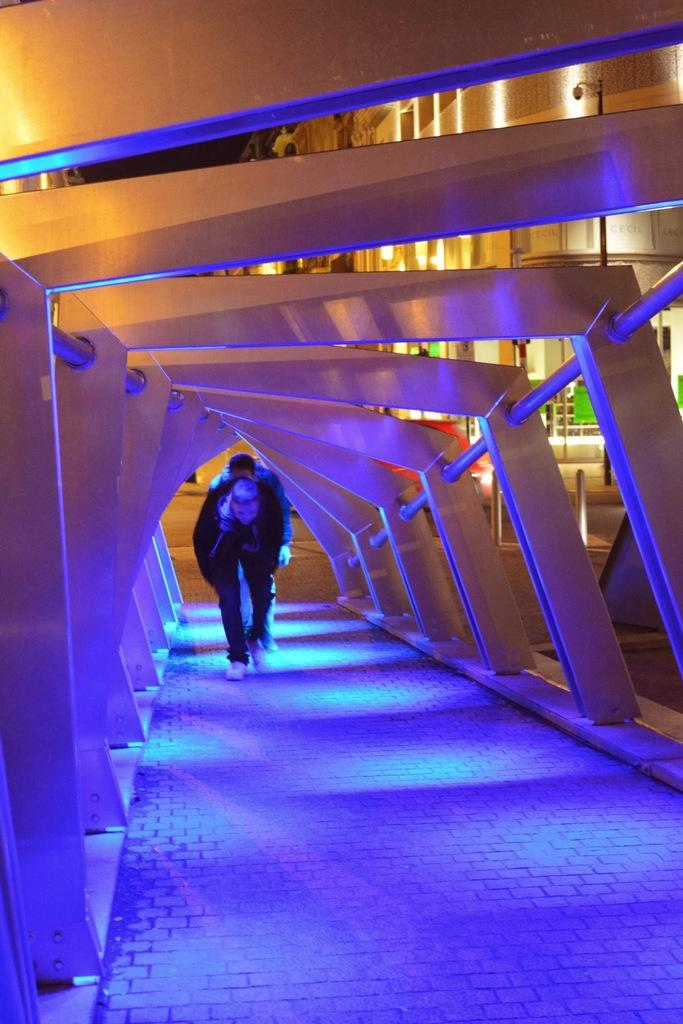How many people are in the image? There are two persons in the image. What are the persons doing in the image? The persons are walking on a walkway. What can be seen in the background of the image? There are buildings and the sky visible in the background of the image. What type of wood can be seen in the image? There is no wood present in the image; it features two persons walking on a walkway with buildings and the sky in the background. What type of breakfast is being prepared in the image? There is no mention of breakfast or any food preparation in the image; it only shows two persons walking on a walkway. 